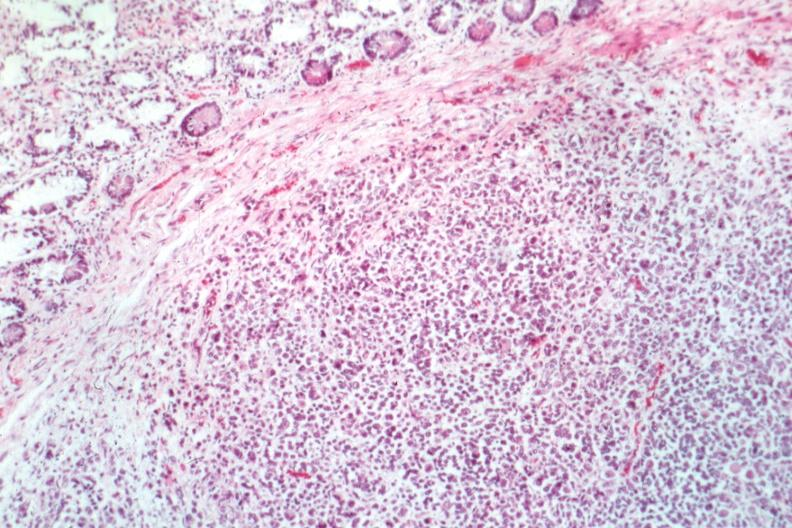s metastatic malignant melanoma present?
Answer the question using a single word or phrase. Yes 